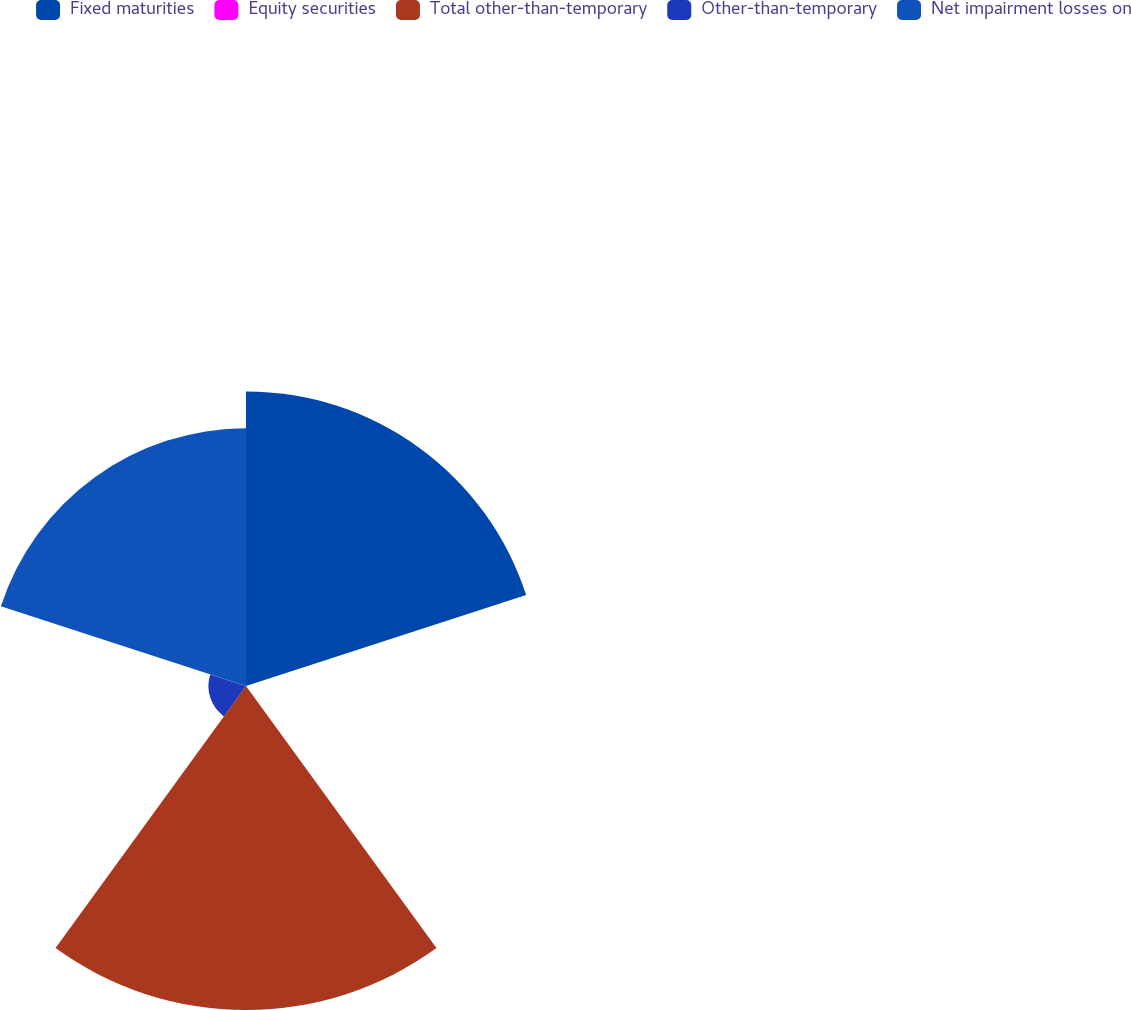<chart> <loc_0><loc_0><loc_500><loc_500><pie_chart><fcel>Fixed maturities<fcel>Equity securities<fcel>Total other-than-temporary<fcel>Other-than-temporary<fcel>Net impairment losses on<nl><fcel>32.2%<fcel>0.1%<fcel>35.42%<fcel>4.11%<fcel>28.18%<nl></chart> 